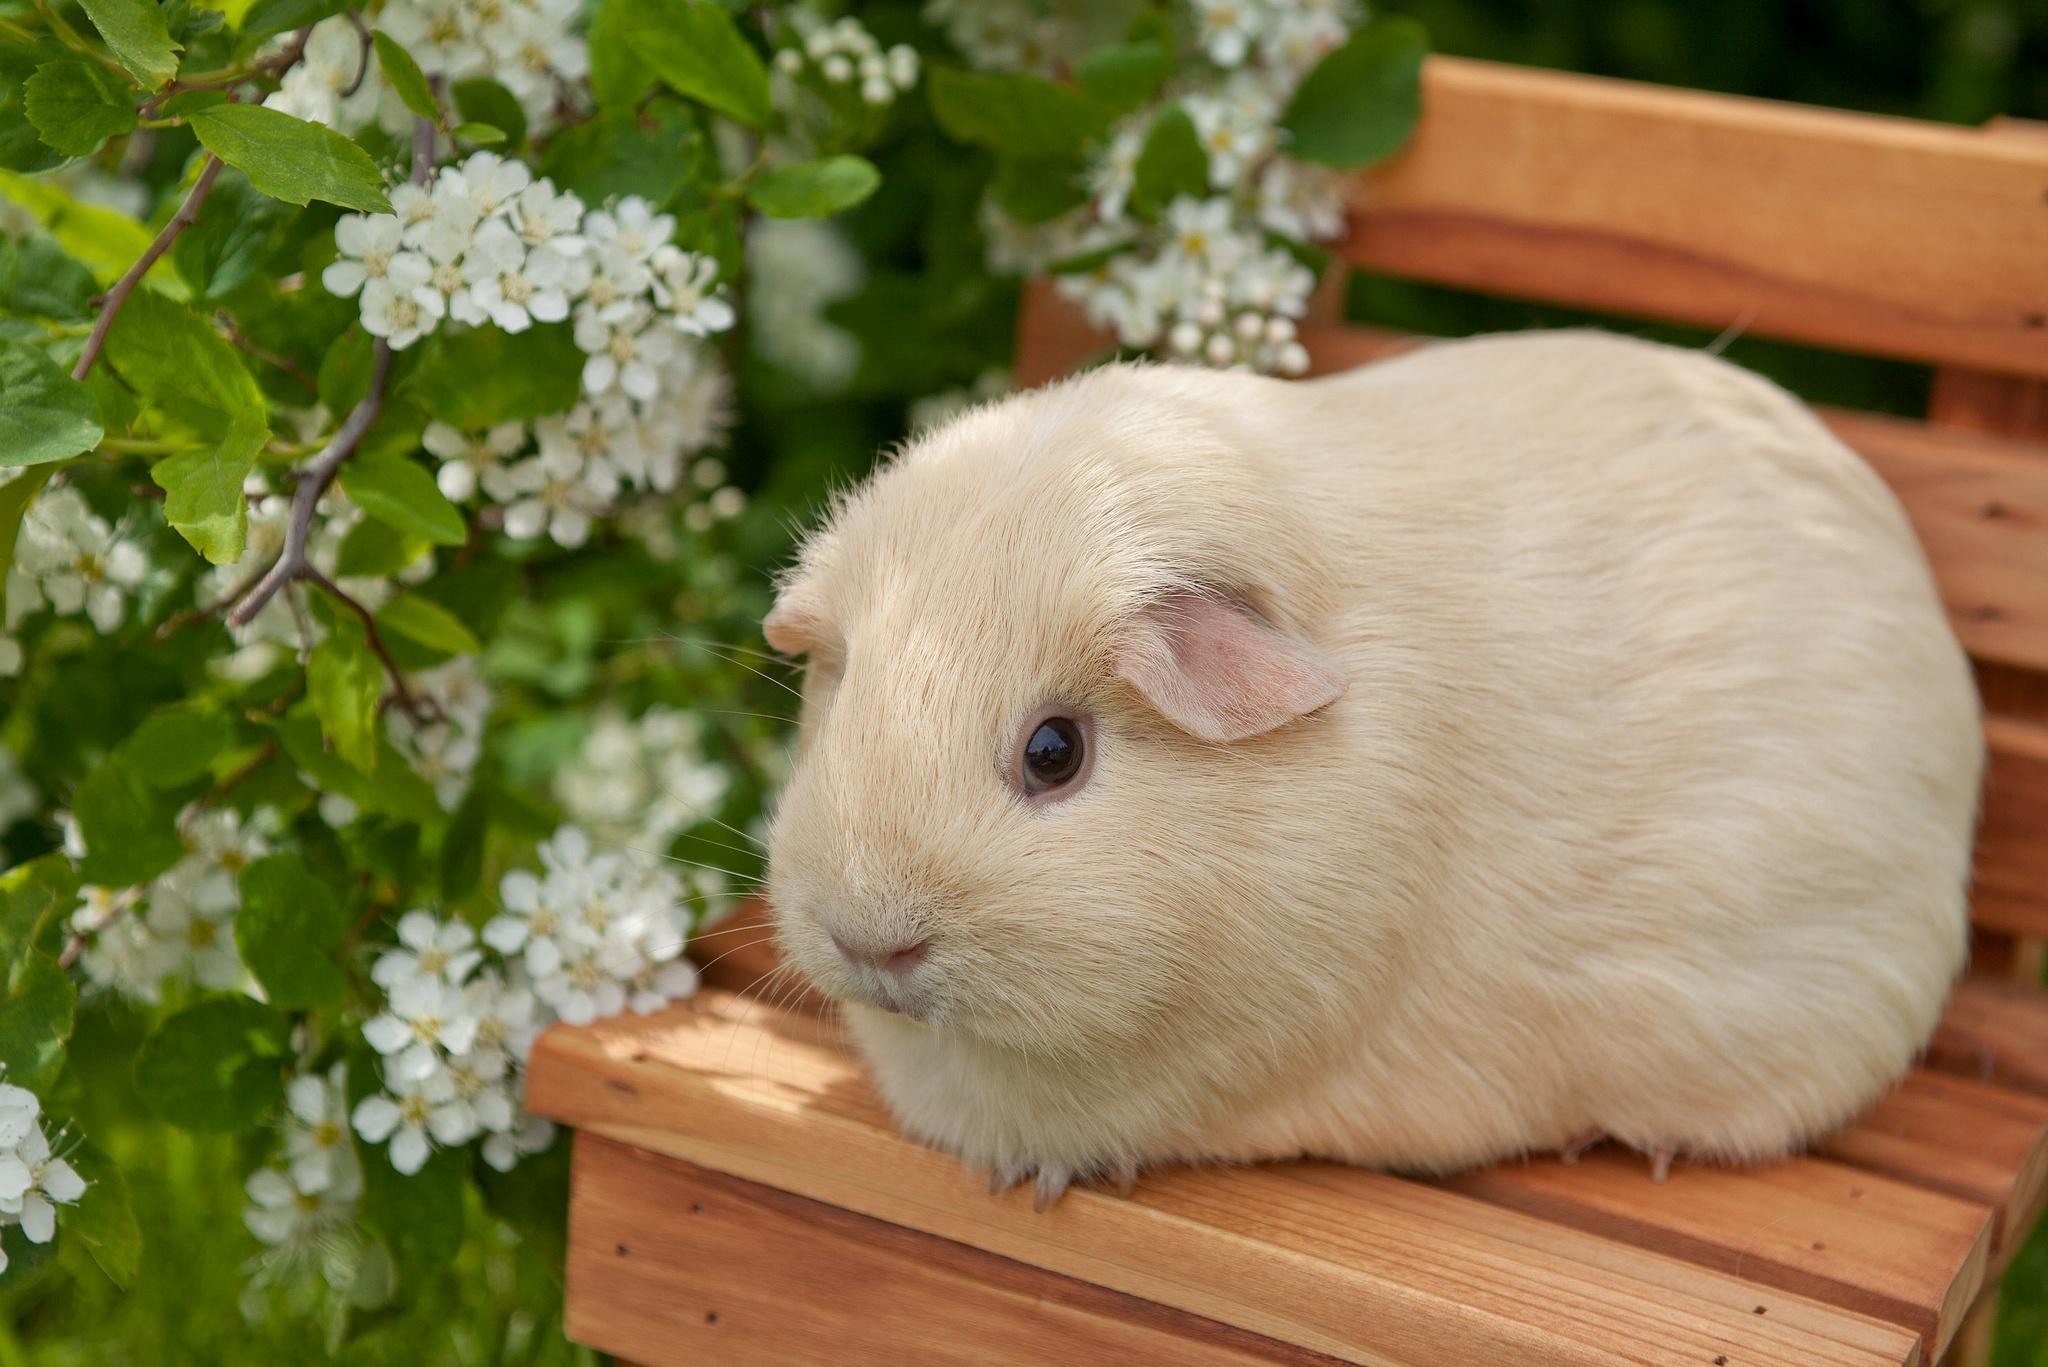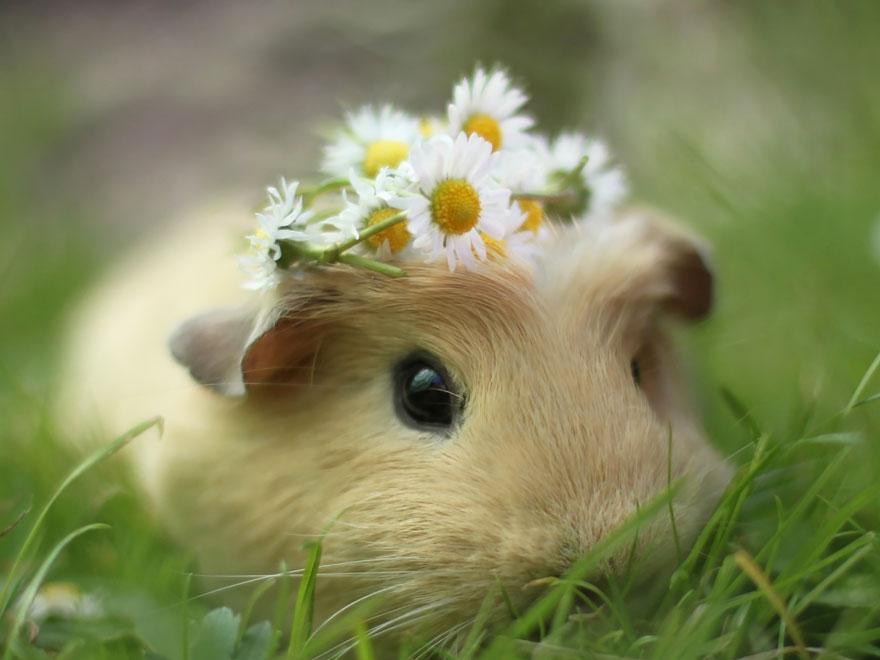The first image is the image on the left, the second image is the image on the right. Assess this claim about the two images: "One of the images shows a guinea pig with daisies on its head.". Correct or not? Answer yes or no. Yes. 